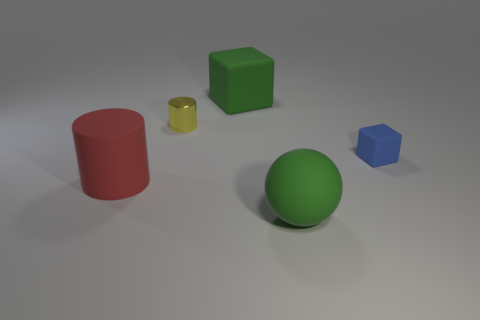Is there anything else that is the same material as the yellow cylinder?
Keep it short and to the point. No. What size is the matte object on the right side of the green matte thing in front of the matte block in front of the tiny metallic object?
Give a very brief answer. Small. What number of yellow metal objects have the same size as the blue rubber block?
Make the answer very short. 1. What number of things are either small metallic cylinders or large matte objects in front of the yellow shiny cylinder?
Offer a terse response. 3. There is a small yellow object; what shape is it?
Provide a short and direct response. Cylinder. Do the large matte cube and the rubber sphere have the same color?
Provide a succinct answer. Yes. There is a sphere that is the same size as the green cube; what is its color?
Give a very brief answer. Green. What number of yellow objects are large spheres or tiny shiny objects?
Your answer should be compact. 1. Is the number of tiny blue rubber things greater than the number of blue metallic things?
Your response must be concise. Yes. There is a green thing behind the big red cylinder; is its size the same as the cylinder that is behind the small blue matte thing?
Give a very brief answer. No. 